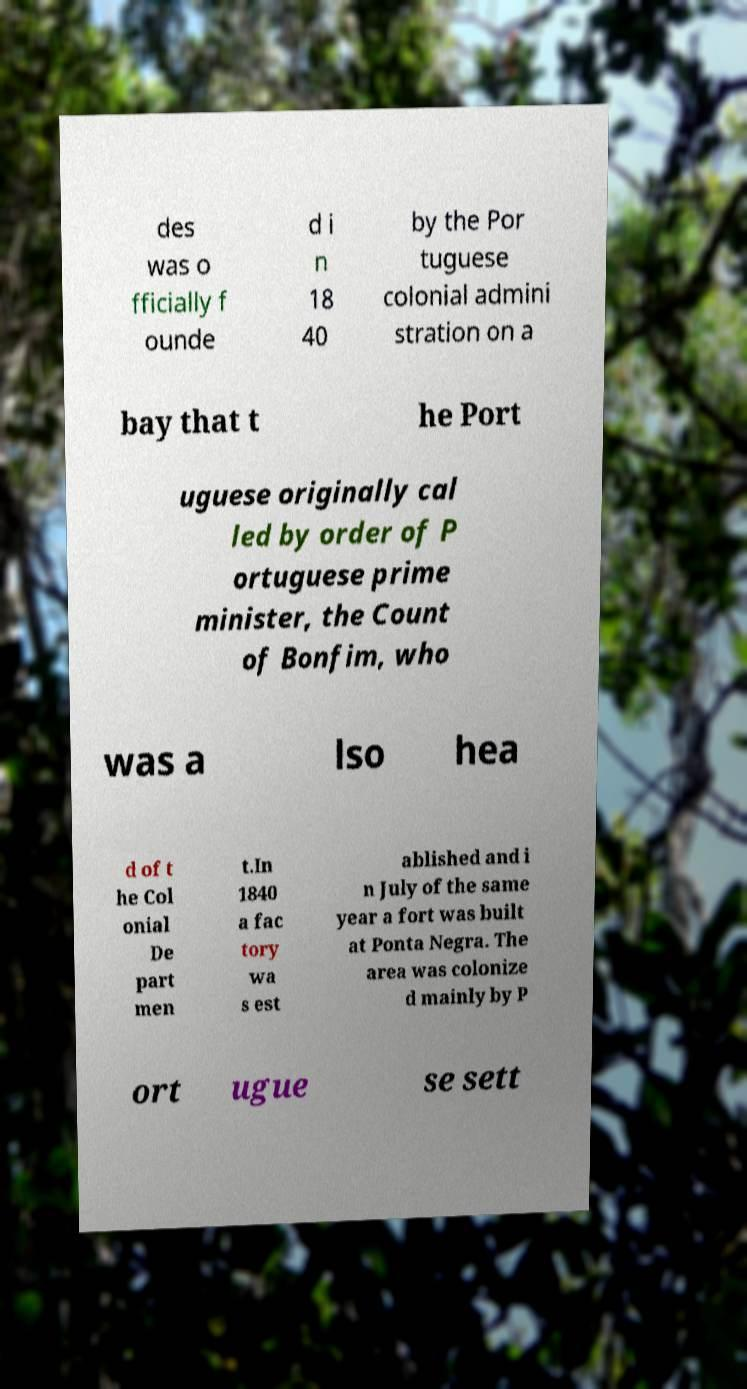Can you accurately transcribe the text from the provided image for me? des was o fficially f ounde d i n 18 40 by the Por tuguese colonial admini stration on a bay that t he Port uguese originally cal led by order of P ortuguese prime minister, the Count of Bonfim, who was a lso hea d of t he Col onial De part men t.In 1840 a fac tory wa s est ablished and i n July of the same year a fort was built at Ponta Negra. The area was colonize d mainly by P ort ugue se sett 